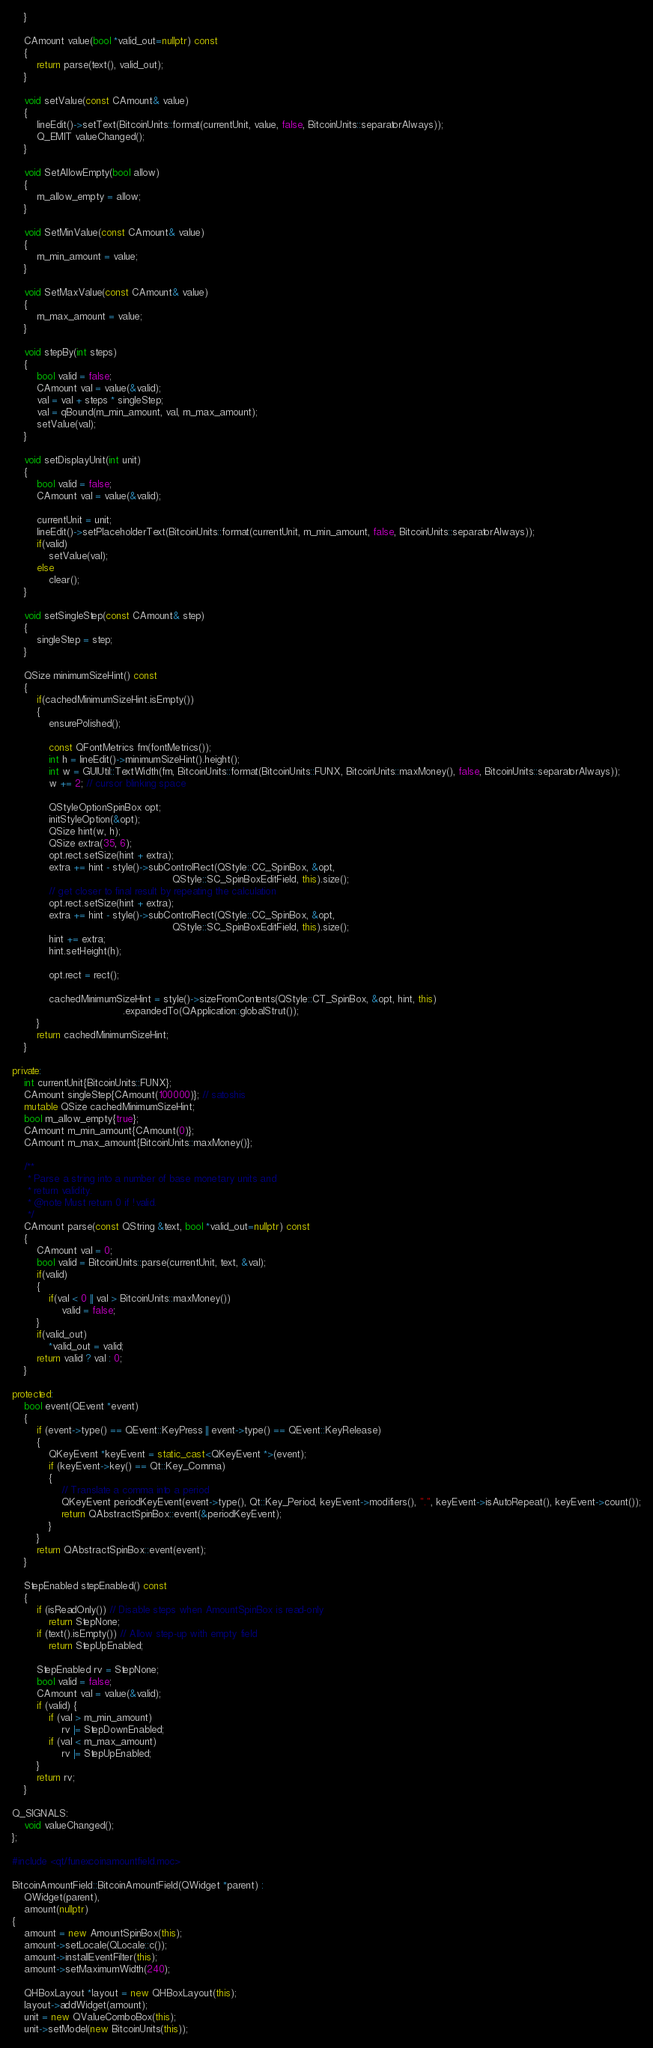Convert code to text. <code><loc_0><loc_0><loc_500><loc_500><_C++_>    }

    CAmount value(bool *valid_out=nullptr) const
    {
        return parse(text(), valid_out);
    }

    void setValue(const CAmount& value)
    {
        lineEdit()->setText(BitcoinUnits::format(currentUnit, value, false, BitcoinUnits::separatorAlways));
        Q_EMIT valueChanged();
    }

    void SetAllowEmpty(bool allow)
    {
        m_allow_empty = allow;
    }

    void SetMinValue(const CAmount& value)
    {
        m_min_amount = value;
    }

    void SetMaxValue(const CAmount& value)
    {
        m_max_amount = value;
    }

    void stepBy(int steps)
    {
        bool valid = false;
        CAmount val = value(&valid);
        val = val + steps * singleStep;
        val = qBound(m_min_amount, val, m_max_amount);
        setValue(val);
    }

    void setDisplayUnit(int unit)
    {
        bool valid = false;
        CAmount val = value(&valid);

        currentUnit = unit;
        lineEdit()->setPlaceholderText(BitcoinUnits::format(currentUnit, m_min_amount, false, BitcoinUnits::separatorAlways));
        if(valid)
            setValue(val);
        else
            clear();
    }

    void setSingleStep(const CAmount& step)
    {
        singleStep = step;
    }

    QSize minimumSizeHint() const
    {
        if(cachedMinimumSizeHint.isEmpty())
        {
            ensurePolished();

            const QFontMetrics fm(fontMetrics());
            int h = lineEdit()->minimumSizeHint().height();
            int w = GUIUtil::TextWidth(fm, BitcoinUnits::format(BitcoinUnits::FUNX, BitcoinUnits::maxMoney(), false, BitcoinUnits::separatorAlways));
            w += 2; // cursor blinking space

            QStyleOptionSpinBox opt;
            initStyleOption(&opt);
            QSize hint(w, h);
            QSize extra(35, 6);
            opt.rect.setSize(hint + extra);
            extra += hint - style()->subControlRect(QStyle::CC_SpinBox, &opt,
                                                    QStyle::SC_SpinBoxEditField, this).size();
            // get closer to final result by repeating the calculation
            opt.rect.setSize(hint + extra);
            extra += hint - style()->subControlRect(QStyle::CC_SpinBox, &opt,
                                                    QStyle::SC_SpinBoxEditField, this).size();
            hint += extra;
            hint.setHeight(h);

            opt.rect = rect();

            cachedMinimumSizeHint = style()->sizeFromContents(QStyle::CT_SpinBox, &opt, hint, this)
                                    .expandedTo(QApplication::globalStrut());
        }
        return cachedMinimumSizeHint;
    }

private:
    int currentUnit{BitcoinUnits::FUNX};
    CAmount singleStep{CAmount(100000)}; // satoshis
    mutable QSize cachedMinimumSizeHint;
    bool m_allow_empty{true};
    CAmount m_min_amount{CAmount(0)};
    CAmount m_max_amount{BitcoinUnits::maxMoney()};

    /**
     * Parse a string into a number of base monetary units and
     * return validity.
     * @note Must return 0 if !valid.
     */
    CAmount parse(const QString &text, bool *valid_out=nullptr) const
    {
        CAmount val = 0;
        bool valid = BitcoinUnits::parse(currentUnit, text, &val);
        if(valid)
        {
            if(val < 0 || val > BitcoinUnits::maxMoney())
                valid = false;
        }
        if(valid_out)
            *valid_out = valid;
        return valid ? val : 0;
    }

protected:
    bool event(QEvent *event)
    {
        if (event->type() == QEvent::KeyPress || event->type() == QEvent::KeyRelease)
        {
            QKeyEvent *keyEvent = static_cast<QKeyEvent *>(event);
            if (keyEvent->key() == Qt::Key_Comma)
            {
                // Translate a comma into a period
                QKeyEvent periodKeyEvent(event->type(), Qt::Key_Period, keyEvent->modifiers(), ".", keyEvent->isAutoRepeat(), keyEvent->count());
                return QAbstractSpinBox::event(&periodKeyEvent);
            }
        }
        return QAbstractSpinBox::event(event);
    }

    StepEnabled stepEnabled() const
    {
        if (isReadOnly()) // Disable steps when AmountSpinBox is read-only
            return StepNone;
        if (text().isEmpty()) // Allow step-up with empty field
            return StepUpEnabled;

        StepEnabled rv = StepNone;
        bool valid = false;
        CAmount val = value(&valid);
        if (valid) {
            if (val > m_min_amount)
                rv |= StepDownEnabled;
            if (val < m_max_amount)
                rv |= StepUpEnabled;
        }
        return rv;
    }

Q_SIGNALS:
    void valueChanged();
};

#include <qt/funexcoinamountfield.moc>

BitcoinAmountField::BitcoinAmountField(QWidget *parent) :
    QWidget(parent),
    amount(nullptr)
{
    amount = new AmountSpinBox(this);
    amount->setLocale(QLocale::c());
    amount->installEventFilter(this);
    amount->setMaximumWidth(240);

    QHBoxLayout *layout = new QHBoxLayout(this);
    layout->addWidget(amount);
    unit = new QValueComboBox(this);
    unit->setModel(new BitcoinUnits(this));</code> 